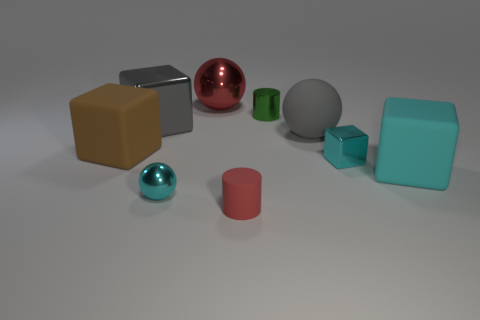How many cyan blocks must be subtracted to get 1 cyan blocks? 1 Subtract all cyan spheres. How many spheres are left? 2 Subtract all balls. How many objects are left? 6 Subtract all cyan cylinders. How many cyan blocks are left? 2 Add 4 tiny cylinders. How many tiny cylinders are left? 6 Add 9 tiny blue matte objects. How many tiny blue matte objects exist? 9 Subtract all red spheres. How many spheres are left? 2 Subtract 1 cyan blocks. How many objects are left? 8 Subtract 1 cylinders. How many cylinders are left? 1 Subtract all brown balls. Subtract all purple cubes. How many balls are left? 3 